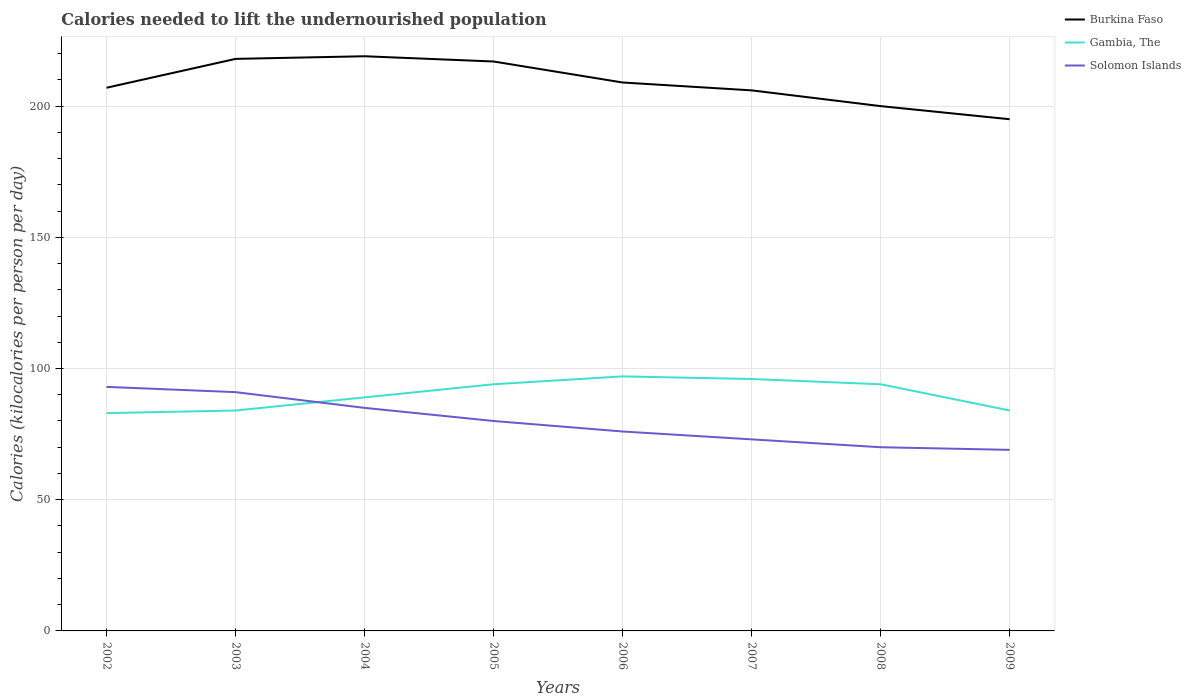Does the line corresponding to Solomon Islands intersect with the line corresponding to Burkina Faso?
Provide a short and direct response. No. Is the number of lines equal to the number of legend labels?
Your answer should be very brief. Yes. Across all years, what is the maximum total calories needed to lift the undernourished population in Gambia, The?
Keep it short and to the point. 83. What is the total total calories needed to lift the undernourished population in Solomon Islands in the graph?
Ensure brevity in your answer.  12. What is the difference between the highest and the second highest total calories needed to lift the undernourished population in Burkina Faso?
Provide a short and direct response. 24. What is the difference between the highest and the lowest total calories needed to lift the undernourished population in Burkina Faso?
Give a very brief answer. 4. What is the difference between two consecutive major ticks on the Y-axis?
Offer a terse response. 50. Does the graph contain grids?
Ensure brevity in your answer.  Yes. Where does the legend appear in the graph?
Ensure brevity in your answer.  Top right. How many legend labels are there?
Make the answer very short. 3. How are the legend labels stacked?
Offer a very short reply. Vertical. What is the title of the graph?
Your response must be concise. Calories needed to lift the undernourished population. What is the label or title of the X-axis?
Provide a short and direct response. Years. What is the label or title of the Y-axis?
Provide a short and direct response. Calories (kilocalories per person per day). What is the Calories (kilocalories per person per day) in Burkina Faso in 2002?
Provide a succinct answer. 207. What is the Calories (kilocalories per person per day) in Gambia, The in 2002?
Make the answer very short. 83. What is the Calories (kilocalories per person per day) in Solomon Islands in 2002?
Your answer should be very brief. 93. What is the Calories (kilocalories per person per day) in Burkina Faso in 2003?
Your answer should be very brief. 218. What is the Calories (kilocalories per person per day) in Gambia, The in 2003?
Ensure brevity in your answer.  84. What is the Calories (kilocalories per person per day) of Solomon Islands in 2003?
Make the answer very short. 91. What is the Calories (kilocalories per person per day) of Burkina Faso in 2004?
Keep it short and to the point. 219. What is the Calories (kilocalories per person per day) in Gambia, The in 2004?
Your response must be concise. 89. What is the Calories (kilocalories per person per day) in Burkina Faso in 2005?
Give a very brief answer. 217. What is the Calories (kilocalories per person per day) of Gambia, The in 2005?
Ensure brevity in your answer.  94. What is the Calories (kilocalories per person per day) of Solomon Islands in 2005?
Give a very brief answer. 80. What is the Calories (kilocalories per person per day) in Burkina Faso in 2006?
Your answer should be compact. 209. What is the Calories (kilocalories per person per day) of Gambia, The in 2006?
Make the answer very short. 97. What is the Calories (kilocalories per person per day) of Burkina Faso in 2007?
Keep it short and to the point. 206. What is the Calories (kilocalories per person per day) of Gambia, The in 2007?
Give a very brief answer. 96. What is the Calories (kilocalories per person per day) of Burkina Faso in 2008?
Provide a succinct answer. 200. What is the Calories (kilocalories per person per day) in Gambia, The in 2008?
Your answer should be very brief. 94. What is the Calories (kilocalories per person per day) in Solomon Islands in 2008?
Your response must be concise. 70. What is the Calories (kilocalories per person per day) of Burkina Faso in 2009?
Your answer should be compact. 195. Across all years, what is the maximum Calories (kilocalories per person per day) in Burkina Faso?
Give a very brief answer. 219. Across all years, what is the maximum Calories (kilocalories per person per day) of Gambia, The?
Provide a short and direct response. 97. Across all years, what is the maximum Calories (kilocalories per person per day) of Solomon Islands?
Your answer should be compact. 93. Across all years, what is the minimum Calories (kilocalories per person per day) of Burkina Faso?
Your response must be concise. 195. Across all years, what is the minimum Calories (kilocalories per person per day) of Solomon Islands?
Ensure brevity in your answer.  69. What is the total Calories (kilocalories per person per day) of Burkina Faso in the graph?
Your answer should be very brief. 1671. What is the total Calories (kilocalories per person per day) of Gambia, The in the graph?
Your answer should be very brief. 721. What is the total Calories (kilocalories per person per day) of Solomon Islands in the graph?
Your response must be concise. 637. What is the difference between the Calories (kilocalories per person per day) in Gambia, The in 2002 and that in 2003?
Your answer should be compact. -1. What is the difference between the Calories (kilocalories per person per day) of Gambia, The in 2002 and that in 2004?
Give a very brief answer. -6. What is the difference between the Calories (kilocalories per person per day) of Solomon Islands in 2002 and that in 2004?
Provide a short and direct response. 8. What is the difference between the Calories (kilocalories per person per day) of Solomon Islands in 2002 and that in 2005?
Make the answer very short. 13. What is the difference between the Calories (kilocalories per person per day) in Burkina Faso in 2002 and that in 2006?
Offer a very short reply. -2. What is the difference between the Calories (kilocalories per person per day) in Gambia, The in 2002 and that in 2007?
Give a very brief answer. -13. What is the difference between the Calories (kilocalories per person per day) in Solomon Islands in 2002 and that in 2007?
Give a very brief answer. 20. What is the difference between the Calories (kilocalories per person per day) of Burkina Faso in 2002 and that in 2009?
Keep it short and to the point. 12. What is the difference between the Calories (kilocalories per person per day) in Gambia, The in 2002 and that in 2009?
Keep it short and to the point. -1. What is the difference between the Calories (kilocalories per person per day) of Gambia, The in 2003 and that in 2004?
Your response must be concise. -5. What is the difference between the Calories (kilocalories per person per day) in Solomon Islands in 2003 and that in 2005?
Ensure brevity in your answer.  11. What is the difference between the Calories (kilocalories per person per day) in Burkina Faso in 2003 and that in 2006?
Ensure brevity in your answer.  9. What is the difference between the Calories (kilocalories per person per day) of Gambia, The in 2003 and that in 2006?
Provide a short and direct response. -13. What is the difference between the Calories (kilocalories per person per day) in Solomon Islands in 2003 and that in 2006?
Offer a very short reply. 15. What is the difference between the Calories (kilocalories per person per day) of Gambia, The in 2003 and that in 2007?
Your response must be concise. -12. What is the difference between the Calories (kilocalories per person per day) in Solomon Islands in 2003 and that in 2007?
Provide a short and direct response. 18. What is the difference between the Calories (kilocalories per person per day) in Burkina Faso in 2003 and that in 2008?
Provide a short and direct response. 18. What is the difference between the Calories (kilocalories per person per day) of Gambia, The in 2003 and that in 2008?
Offer a terse response. -10. What is the difference between the Calories (kilocalories per person per day) in Burkina Faso in 2003 and that in 2009?
Your answer should be compact. 23. What is the difference between the Calories (kilocalories per person per day) in Gambia, The in 2003 and that in 2009?
Ensure brevity in your answer.  0. What is the difference between the Calories (kilocalories per person per day) of Solomon Islands in 2003 and that in 2009?
Provide a short and direct response. 22. What is the difference between the Calories (kilocalories per person per day) in Burkina Faso in 2004 and that in 2005?
Offer a terse response. 2. What is the difference between the Calories (kilocalories per person per day) in Gambia, The in 2004 and that in 2005?
Your answer should be very brief. -5. What is the difference between the Calories (kilocalories per person per day) in Solomon Islands in 2004 and that in 2005?
Ensure brevity in your answer.  5. What is the difference between the Calories (kilocalories per person per day) in Gambia, The in 2004 and that in 2006?
Your answer should be very brief. -8. What is the difference between the Calories (kilocalories per person per day) in Burkina Faso in 2004 and that in 2007?
Ensure brevity in your answer.  13. What is the difference between the Calories (kilocalories per person per day) of Solomon Islands in 2004 and that in 2007?
Give a very brief answer. 12. What is the difference between the Calories (kilocalories per person per day) in Gambia, The in 2004 and that in 2008?
Provide a short and direct response. -5. What is the difference between the Calories (kilocalories per person per day) of Solomon Islands in 2004 and that in 2008?
Provide a succinct answer. 15. What is the difference between the Calories (kilocalories per person per day) of Solomon Islands in 2004 and that in 2009?
Your answer should be compact. 16. What is the difference between the Calories (kilocalories per person per day) of Burkina Faso in 2005 and that in 2006?
Your answer should be compact. 8. What is the difference between the Calories (kilocalories per person per day) of Gambia, The in 2005 and that in 2006?
Make the answer very short. -3. What is the difference between the Calories (kilocalories per person per day) of Solomon Islands in 2005 and that in 2006?
Give a very brief answer. 4. What is the difference between the Calories (kilocalories per person per day) in Solomon Islands in 2005 and that in 2007?
Give a very brief answer. 7. What is the difference between the Calories (kilocalories per person per day) of Burkina Faso in 2005 and that in 2008?
Your answer should be compact. 17. What is the difference between the Calories (kilocalories per person per day) in Solomon Islands in 2005 and that in 2008?
Offer a very short reply. 10. What is the difference between the Calories (kilocalories per person per day) in Burkina Faso in 2005 and that in 2009?
Provide a short and direct response. 22. What is the difference between the Calories (kilocalories per person per day) of Gambia, The in 2005 and that in 2009?
Ensure brevity in your answer.  10. What is the difference between the Calories (kilocalories per person per day) in Solomon Islands in 2005 and that in 2009?
Your response must be concise. 11. What is the difference between the Calories (kilocalories per person per day) of Gambia, The in 2006 and that in 2007?
Your answer should be very brief. 1. What is the difference between the Calories (kilocalories per person per day) of Gambia, The in 2007 and that in 2009?
Ensure brevity in your answer.  12. What is the difference between the Calories (kilocalories per person per day) in Solomon Islands in 2007 and that in 2009?
Your answer should be compact. 4. What is the difference between the Calories (kilocalories per person per day) in Burkina Faso in 2008 and that in 2009?
Offer a very short reply. 5. What is the difference between the Calories (kilocalories per person per day) of Solomon Islands in 2008 and that in 2009?
Your answer should be very brief. 1. What is the difference between the Calories (kilocalories per person per day) of Burkina Faso in 2002 and the Calories (kilocalories per person per day) of Gambia, The in 2003?
Provide a succinct answer. 123. What is the difference between the Calories (kilocalories per person per day) in Burkina Faso in 2002 and the Calories (kilocalories per person per day) in Solomon Islands in 2003?
Your answer should be very brief. 116. What is the difference between the Calories (kilocalories per person per day) in Burkina Faso in 2002 and the Calories (kilocalories per person per day) in Gambia, The in 2004?
Offer a terse response. 118. What is the difference between the Calories (kilocalories per person per day) of Burkina Faso in 2002 and the Calories (kilocalories per person per day) of Solomon Islands in 2004?
Your response must be concise. 122. What is the difference between the Calories (kilocalories per person per day) of Gambia, The in 2002 and the Calories (kilocalories per person per day) of Solomon Islands in 2004?
Offer a terse response. -2. What is the difference between the Calories (kilocalories per person per day) of Burkina Faso in 2002 and the Calories (kilocalories per person per day) of Gambia, The in 2005?
Keep it short and to the point. 113. What is the difference between the Calories (kilocalories per person per day) in Burkina Faso in 2002 and the Calories (kilocalories per person per day) in Solomon Islands in 2005?
Make the answer very short. 127. What is the difference between the Calories (kilocalories per person per day) in Gambia, The in 2002 and the Calories (kilocalories per person per day) in Solomon Islands in 2005?
Offer a terse response. 3. What is the difference between the Calories (kilocalories per person per day) of Burkina Faso in 2002 and the Calories (kilocalories per person per day) of Gambia, The in 2006?
Offer a terse response. 110. What is the difference between the Calories (kilocalories per person per day) in Burkina Faso in 2002 and the Calories (kilocalories per person per day) in Solomon Islands in 2006?
Offer a terse response. 131. What is the difference between the Calories (kilocalories per person per day) of Gambia, The in 2002 and the Calories (kilocalories per person per day) of Solomon Islands in 2006?
Provide a short and direct response. 7. What is the difference between the Calories (kilocalories per person per day) of Burkina Faso in 2002 and the Calories (kilocalories per person per day) of Gambia, The in 2007?
Keep it short and to the point. 111. What is the difference between the Calories (kilocalories per person per day) in Burkina Faso in 2002 and the Calories (kilocalories per person per day) in Solomon Islands in 2007?
Offer a terse response. 134. What is the difference between the Calories (kilocalories per person per day) of Burkina Faso in 2002 and the Calories (kilocalories per person per day) of Gambia, The in 2008?
Your answer should be very brief. 113. What is the difference between the Calories (kilocalories per person per day) of Burkina Faso in 2002 and the Calories (kilocalories per person per day) of Solomon Islands in 2008?
Keep it short and to the point. 137. What is the difference between the Calories (kilocalories per person per day) in Burkina Faso in 2002 and the Calories (kilocalories per person per day) in Gambia, The in 2009?
Give a very brief answer. 123. What is the difference between the Calories (kilocalories per person per day) in Burkina Faso in 2002 and the Calories (kilocalories per person per day) in Solomon Islands in 2009?
Offer a terse response. 138. What is the difference between the Calories (kilocalories per person per day) of Gambia, The in 2002 and the Calories (kilocalories per person per day) of Solomon Islands in 2009?
Make the answer very short. 14. What is the difference between the Calories (kilocalories per person per day) in Burkina Faso in 2003 and the Calories (kilocalories per person per day) in Gambia, The in 2004?
Offer a terse response. 129. What is the difference between the Calories (kilocalories per person per day) in Burkina Faso in 2003 and the Calories (kilocalories per person per day) in Solomon Islands in 2004?
Your answer should be compact. 133. What is the difference between the Calories (kilocalories per person per day) of Burkina Faso in 2003 and the Calories (kilocalories per person per day) of Gambia, The in 2005?
Provide a short and direct response. 124. What is the difference between the Calories (kilocalories per person per day) in Burkina Faso in 2003 and the Calories (kilocalories per person per day) in Solomon Islands in 2005?
Keep it short and to the point. 138. What is the difference between the Calories (kilocalories per person per day) of Gambia, The in 2003 and the Calories (kilocalories per person per day) of Solomon Islands in 2005?
Your answer should be compact. 4. What is the difference between the Calories (kilocalories per person per day) in Burkina Faso in 2003 and the Calories (kilocalories per person per day) in Gambia, The in 2006?
Your answer should be very brief. 121. What is the difference between the Calories (kilocalories per person per day) of Burkina Faso in 2003 and the Calories (kilocalories per person per day) of Solomon Islands in 2006?
Make the answer very short. 142. What is the difference between the Calories (kilocalories per person per day) in Gambia, The in 2003 and the Calories (kilocalories per person per day) in Solomon Islands in 2006?
Offer a very short reply. 8. What is the difference between the Calories (kilocalories per person per day) in Burkina Faso in 2003 and the Calories (kilocalories per person per day) in Gambia, The in 2007?
Make the answer very short. 122. What is the difference between the Calories (kilocalories per person per day) in Burkina Faso in 2003 and the Calories (kilocalories per person per day) in Solomon Islands in 2007?
Make the answer very short. 145. What is the difference between the Calories (kilocalories per person per day) in Burkina Faso in 2003 and the Calories (kilocalories per person per day) in Gambia, The in 2008?
Your answer should be very brief. 124. What is the difference between the Calories (kilocalories per person per day) of Burkina Faso in 2003 and the Calories (kilocalories per person per day) of Solomon Islands in 2008?
Provide a succinct answer. 148. What is the difference between the Calories (kilocalories per person per day) of Burkina Faso in 2003 and the Calories (kilocalories per person per day) of Gambia, The in 2009?
Make the answer very short. 134. What is the difference between the Calories (kilocalories per person per day) in Burkina Faso in 2003 and the Calories (kilocalories per person per day) in Solomon Islands in 2009?
Provide a succinct answer. 149. What is the difference between the Calories (kilocalories per person per day) in Gambia, The in 2003 and the Calories (kilocalories per person per day) in Solomon Islands in 2009?
Keep it short and to the point. 15. What is the difference between the Calories (kilocalories per person per day) of Burkina Faso in 2004 and the Calories (kilocalories per person per day) of Gambia, The in 2005?
Ensure brevity in your answer.  125. What is the difference between the Calories (kilocalories per person per day) of Burkina Faso in 2004 and the Calories (kilocalories per person per day) of Solomon Islands in 2005?
Your answer should be compact. 139. What is the difference between the Calories (kilocalories per person per day) in Burkina Faso in 2004 and the Calories (kilocalories per person per day) in Gambia, The in 2006?
Give a very brief answer. 122. What is the difference between the Calories (kilocalories per person per day) of Burkina Faso in 2004 and the Calories (kilocalories per person per day) of Solomon Islands in 2006?
Provide a short and direct response. 143. What is the difference between the Calories (kilocalories per person per day) of Burkina Faso in 2004 and the Calories (kilocalories per person per day) of Gambia, The in 2007?
Your response must be concise. 123. What is the difference between the Calories (kilocalories per person per day) in Burkina Faso in 2004 and the Calories (kilocalories per person per day) in Solomon Islands in 2007?
Your answer should be very brief. 146. What is the difference between the Calories (kilocalories per person per day) in Burkina Faso in 2004 and the Calories (kilocalories per person per day) in Gambia, The in 2008?
Your response must be concise. 125. What is the difference between the Calories (kilocalories per person per day) in Burkina Faso in 2004 and the Calories (kilocalories per person per day) in Solomon Islands in 2008?
Provide a short and direct response. 149. What is the difference between the Calories (kilocalories per person per day) of Burkina Faso in 2004 and the Calories (kilocalories per person per day) of Gambia, The in 2009?
Offer a terse response. 135. What is the difference between the Calories (kilocalories per person per day) of Burkina Faso in 2004 and the Calories (kilocalories per person per day) of Solomon Islands in 2009?
Offer a terse response. 150. What is the difference between the Calories (kilocalories per person per day) in Gambia, The in 2004 and the Calories (kilocalories per person per day) in Solomon Islands in 2009?
Offer a very short reply. 20. What is the difference between the Calories (kilocalories per person per day) of Burkina Faso in 2005 and the Calories (kilocalories per person per day) of Gambia, The in 2006?
Give a very brief answer. 120. What is the difference between the Calories (kilocalories per person per day) of Burkina Faso in 2005 and the Calories (kilocalories per person per day) of Solomon Islands in 2006?
Your answer should be compact. 141. What is the difference between the Calories (kilocalories per person per day) in Gambia, The in 2005 and the Calories (kilocalories per person per day) in Solomon Islands in 2006?
Make the answer very short. 18. What is the difference between the Calories (kilocalories per person per day) of Burkina Faso in 2005 and the Calories (kilocalories per person per day) of Gambia, The in 2007?
Make the answer very short. 121. What is the difference between the Calories (kilocalories per person per day) of Burkina Faso in 2005 and the Calories (kilocalories per person per day) of Solomon Islands in 2007?
Ensure brevity in your answer.  144. What is the difference between the Calories (kilocalories per person per day) of Gambia, The in 2005 and the Calories (kilocalories per person per day) of Solomon Islands in 2007?
Provide a succinct answer. 21. What is the difference between the Calories (kilocalories per person per day) of Burkina Faso in 2005 and the Calories (kilocalories per person per day) of Gambia, The in 2008?
Provide a short and direct response. 123. What is the difference between the Calories (kilocalories per person per day) of Burkina Faso in 2005 and the Calories (kilocalories per person per day) of Solomon Islands in 2008?
Offer a very short reply. 147. What is the difference between the Calories (kilocalories per person per day) of Gambia, The in 2005 and the Calories (kilocalories per person per day) of Solomon Islands in 2008?
Your response must be concise. 24. What is the difference between the Calories (kilocalories per person per day) in Burkina Faso in 2005 and the Calories (kilocalories per person per day) in Gambia, The in 2009?
Your answer should be very brief. 133. What is the difference between the Calories (kilocalories per person per day) of Burkina Faso in 2005 and the Calories (kilocalories per person per day) of Solomon Islands in 2009?
Offer a terse response. 148. What is the difference between the Calories (kilocalories per person per day) of Gambia, The in 2005 and the Calories (kilocalories per person per day) of Solomon Islands in 2009?
Give a very brief answer. 25. What is the difference between the Calories (kilocalories per person per day) of Burkina Faso in 2006 and the Calories (kilocalories per person per day) of Gambia, The in 2007?
Provide a succinct answer. 113. What is the difference between the Calories (kilocalories per person per day) in Burkina Faso in 2006 and the Calories (kilocalories per person per day) in Solomon Islands in 2007?
Provide a short and direct response. 136. What is the difference between the Calories (kilocalories per person per day) of Burkina Faso in 2006 and the Calories (kilocalories per person per day) of Gambia, The in 2008?
Ensure brevity in your answer.  115. What is the difference between the Calories (kilocalories per person per day) in Burkina Faso in 2006 and the Calories (kilocalories per person per day) in Solomon Islands in 2008?
Your answer should be compact. 139. What is the difference between the Calories (kilocalories per person per day) in Burkina Faso in 2006 and the Calories (kilocalories per person per day) in Gambia, The in 2009?
Offer a very short reply. 125. What is the difference between the Calories (kilocalories per person per day) in Burkina Faso in 2006 and the Calories (kilocalories per person per day) in Solomon Islands in 2009?
Provide a short and direct response. 140. What is the difference between the Calories (kilocalories per person per day) in Gambia, The in 2006 and the Calories (kilocalories per person per day) in Solomon Islands in 2009?
Provide a succinct answer. 28. What is the difference between the Calories (kilocalories per person per day) in Burkina Faso in 2007 and the Calories (kilocalories per person per day) in Gambia, The in 2008?
Offer a very short reply. 112. What is the difference between the Calories (kilocalories per person per day) in Burkina Faso in 2007 and the Calories (kilocalories per person per day) in Solomon Islands in 2008?
Ensure brevity in your answer.  136. What is the difference between the Calories (kilocalories per person per day) of Burkina Faso in 2007 and the Calories (kilocalories per person per day) of Gambia, The in 2009?
Offer a very short reply. 122. What is the difference between the Calories (kilocalories per person per day) in Burkina Faso in 2007 and the Calories (kilocalories per person per day) in Solomon Islands in 2009?
Provide a succinct answer. 137. What is the difference between the Calories (kilocalories per person per day) of Gambia, The in 2007 and the Calories (kilocalories per person per day) of Solomon Islands in 2009?
Your response must be concise. 27. What is the difference between the Calories (kilocalories per person per day) in Burkina Faso in 2008 and the Calories (kilocalories per person per day) in Gambia, The in 2009?
Provide a succinct answer. 116. What is the difference between the Calories (kilocalories per person per day) in Burkina Faso in 2008 and the Calories (kilocalories per person per day) in Solomon Islands in 2009?
Keep it short and to the point. 131. What is the difference between the Calories (kilocalories per person per day) in Gambia, The in 2008 and the Calories (kilocalories per person per day) in Solomon Islands in 2009?
Give a very brief answer. 25. What is the average Calories (kilocalories per person per day) of Burkina Faso per year?
Your answer should be very brief. 208.88. What is the average Calories (kilocalories per person per day) in Gambia, The per year?
Your answer should be compact. 90.12. What is the average Calories (kilocalories per person per day) in Solomon Islands per year?
Offer a very short reply. 79.62. In the year 2002, what is the difference between the Calories (kilocalories per person per day) in Burkina Faso and Calories (kilocalories per person per day) in Gambia, The?
Provide a succinct answer. 124. In the year 2002, what is the difference between the Calories (kilocalories per person per day) of Burkina Faso and Calories (kilocalories per person per day) of Solomon Islands?
Provide a short and direct response. 114. In the year 2003, what is the difference between the Calories (kilocalories per person per day) in Burkina Faso and Calories (kilocalories per person per day) in Gambia, The?
Provide a succinct answer. 134. In the year 2003, what is the difference between the Calories (kilocalories per person per day) of Burkina Faso and Calories (kilocalories per person per day) of Solomon Islands?
Ensure brevity in your answer.  127. In the year 2003, what is the difference between the Calories (kilocalories per person per day) in Gambia, The and Calories (kilocalories per person per day) in Solomon Islands?
Your answer should be compact. -7. In the year 2004, what is the difference between the Calories (kilocalories per person per day) in Burkina Faso and Calories (kilocalories per person per day) in Gambia, The?
Provide a succinct answer. 130. In the year 2004, what is the difference between the Calories (kilocalories per person per day) in Burkina Faso and Calories (kilocalories per person per day) in Solomon Islands?
Make the answer very short. 134. In the year 2004, what is the difference between the Calories (kilocalories per person per day) of Gambia, The and Calories (kilocalories per person per day) of Solomon Islands?
Your response must be concise. 4. In the year 2005, what is the difference between the Calories (kilocalories per person per day) of Burkina Faso and Calories (kilocalories per person per day) of Gambia, The?
Provide a succinct answer. 123. In the year 2005, what is the difference between the Calories (kilocalories per person per day) in Burkina Faso and Calories (kilocalories per person per day) in Solomon Islands?
Your answer should be compact. 137. In the year 2005, what is the difference between the Calories (kilocalories per person per day) in Gambia, The and Calories (kilocalories per person per day) in Solomon Islands?
Make the answer very short. 14. In the year 2006, what is the difference between the Calories (kilocalories per person per day) in Burkina Faso and Calories (kilocalories per person per day) in Gambia, The?
Keep it short and to the point. 112. In the year 2006, what is the difference between the Calories (kilocalories per person per day) in Burkina Faso and Calories (kilocalories per person per day) in Solomon Islands?
Keep it short and to the point. 133. In the year 2007, what is the difference between the Calories (kilocalories per person per day) in Burkina Faso and Calories (kilocalories per person per day) in Gambia, The?
Ensure brevity in your answer.  110. In the year 2007, what is the difference between the Calories (kilocalories per person per day) in Burkina Faso and Calories (kilocalories per person per day) in Solomon Islands?
Your answer should be compact. 133. In the year 2008, what is the difference between the Calories (kilocalories per person per day) of Burkina Faso and Calories (kilocalories per person per day) of Gambia, The?
Make the answer very short. 106. In the year 2008, what is the difference between the Calories (kilocalories per person per day) of Burkina Faso and Calories (kilocalories per person per day) of Solomon Islands?
Your response must be concise. 130. In the year 2009, what is the difference between the Calories (kilocalories per person per day) in Burkina Faso and Calories (kilocalories per person per day) in Gambia, The?
Your answer should be compact. 111. In the year 2009, what is the difference between the Calories (kilocalories per person per day) of Burkina Faso and Calories (kilocalories per person per day) of Solomon Islands?
Your answer should be very brief. 126. In the year 2009, what is the difference between the Calories (kilocalories per person per day) of Gambia, The and Calories (kilocalories per person per day) of Solomon Islands?
Keep it short and to the point. 15. What is the ratio of the Calories (kilocalories per person per day) in Burkina Faso in 2002 to that in 2003?
Provide a succinct answer. 0.95. What is the ratio of the Calories (kilocalories per person per day) in Burkina Faso in 2002 to that in 2004?
Provide a short and direct response. 0.95. What is the ratio of the Calories (kilocalories per person per day) of Gambia, The in 2002 to that in 2004?
Your response must be concise. 0.93. What is the ratio of the Calories (kilocalories per person per day) of Solomon Islands in 2002 to that in 2004?
Provide a short and direct response. 1.09. What is the ratio of the Calories (kilocalories per person per day) of Burkina Faso in 2002 to that in 2005?
Your response must be concise. 0.95. What is the ratio of the Calories (kilocalories per person per day) in Gambia, The in 2002 to that in 2005?
Your answer should be compact. 0.88. What is the ratio of the Calories (kilocalories per person per day) of Solomon Islands in 2002 to that in 2005?
Give a very brief answer. 1.16. What is the ratio of the Calories (kilocalories per person per day) in Burkina Faso in 2002 to that in 2006?
Provide a succinct answer. 0.99. What is the ratio of the Calories (kilocalories per person per day) of Gambia, The in 2002 to that in 2006?
Provide a short and direct response. 0.86. What is the ratio of the Calories (kilocalories per person per day) of Solomon Islands in 2002 to that in 2006?
Your answer should be very brief. 1.22. What is the ratio of the Calories (kilocalories per person per day) in Burkina Faso in 2002 to that in 2007?
Your response must be concise. 1. What is the ratio of the Calories (kilocalories per person per day) in Gambia, The in 2002 to that in 2007?
Your answer should be very brief. 0.86. What is the ratio of the Calories (kilocalories per person per day) in Solomon Islands in 2002 to that in 2007?
Your answer should be very brief. 1.27. What is the ratio of the Calories (kilocalories per person per day) of Burkina Faso in 2002 to that in 2008?
Give a very brief answer. 1.03. What is the ratio of the Calories (kilocalories per person per day) in Gambia, The in 2002 to that in 2008?
Provide a short and direct response. 0.88. What is the ratio of the Calories (kilocalories per person per day) of Solomon Islands in 2002 to that in 2008?
Your response must be concise. 1.33. What is the ratio of the Calories (kilocalories per person per day) of Burkina Faso in 2002 to that in 2009?
Offer a very short reply. 1.06. What is the ratio of the Calories (kilocalories per person per day) of Gambia, The in 2002 to that in 2009?
Offer a terse response. 0.99. What is the ratio of the Calories (kilocalories per person per day) of Solomon Islands in 2002 to that in 2009?
Make the answer very short. 1.35. What is the ratio of the Calories (kilocalories per person per day) of Burkina Faso in 2003 to that in 2004?
Provide a short and direct response. 1. What is the ratio of the Calories (kilocalories per person per day) in Gambia, The in 2003 to that in 2004?
Your answer should be very brief. 0.94. What is the ratio of the Calories (kilocalories per person per day) of Solomon Islands in 2003 to that in 2004?
Keep it short and to the point. 1.07. What is the ratio of the Calories (kilocalories per person per day) of Gambia, The in 2003 to that in 2005?
Give a very brief answer. 0.89. What is the ratio of the Calories (kilocalories per person per day) in Solomon Islands in 2003 to that in 2005?
Make the answer very short. 1.14. What is the ratio of the Calories (kilocalories per person per day) of Burkina Faso in 2003 to that in 2006?
Make the answer very short. 1.04. What is the ratio of the Calories (kilocalories per person per day) in Gambia, The in 2003 to that in 2006?
Provide a short and direct response. 0.87. What is the ratio of the Calories (kilocalories per person per day) of Solomon Islands in 2003 to that in 2006?
Ensure brevity in your answer.  1.2. What is the ratio of the Calories (kilocalories per person per day) of Burkina Faso in 2003 to that in 2007?
Make the answer very short. 1.06. What is the ratio of the Calories (kilocalories per person per day) in Solomon Islands in 2003 to that in 2007?
Provide a short and direct response. 1.25. What is the ratio of the Calories (kilocalories per person per day) in Burkina Faso in 2003 to that in 2008?
Ensure brevity in your answer.  1.09. What is the ratio of the Calories (kilocalories per person per day) of Gambia, The in 2003 to that in 2008?
Provide a succinct answer. 0.89. What is the ratio of the Calories (kilocalories per person per day) in Solomon Islands in 2003 to that in 2008?
Your answer should be compact. 1.3. What is the ratio of the Calories (kilocalories per person per day) of Burkina Faso in 2003 to that in 2009?
Your answer should be very brief. 1.12. What is the ratio of the Calories (kilocalories per person per day) in Gambia, The in 2003 to that in 2009?
Give a very brief answer. 1. What is the ratio of the Calories (kilocalories per person per day) in Solomon Islands in 2003 to that in 2009?
Keep it short and to the point. 1.32. What is the ratio of the Calories (kilocalories per person per day) of Burkina Faso in 2004 to that in 2005?
Your response must be concise. 1.01. What is the ratio of the Calories (kilocalories per person per day) in Gambia, The in 2004 to that in 2005?
Your answer should be compact. 0.95. What is the ratio of the Calories (kilocalories per person per day) of Burkina Faso in 2004 to that in 2006?
Your answer should be compact. 1.05. What is the ratio of the Calories (kilocalories per person per day) in Gambia, The in 2004 to that in 2006?
Give a very brief answer. 0.92. What is the ratio of the Calories (kilocalories per person per day) of Solomon Islands in 2004 to that in 2006?
Provide a succinct answer. 1.12. What is the ratio of the Calories (kilocalories per person per day) in Burkina Faso in 2004 to that in 2007?
Give a very brief answer. 1.06. What is the ratio of the Calories (kilocalories per person per day) of Gambia, The in 2004 to that in 2007?
Provide a succinct answer. 0.93. What is the ratio of the Calories (kilocalories per person per day) in Solomon Islands in 2004 to that in 2007?
Give a very brief answer. 1.16. What is the ratio of the Calories (kilocalories per person per day) in Burkina Faso in 2004 to that in 2008?
Keep it short and to the point. 1.09. What is the ratio of the Calories (kilocalories per person per day) in Gambia, The in 2004 to that in 2008?
Offer a very short reply. 0.95. What is the ratio of the Calories (kilocalories per person per day) in Solomon Islands in 2004 to that in 2008?
Give a very brief answer. 1.21. What is the ratio of the Calories (kilocalories per person per day) of Burkina Faso in 2004 to that in 2009?
Your answer should be very brief. 1.12. What is the ratio of the Calories (kilocalories per person per day) in Gambia, The in 2004 to that in 2009?
Ensure brevity in your answer.  1.06. What is the ratio of the Calories (kilocalories per person per day) of Solomon Islands in 2004 to that in 2009?
Your answer should be very brief. 1.23. What is the ratio of the Calories (kilocalories per person per day) in Burkina Faso in 2005 to that in 2006?
Offer a very short reply. 1.04. What is the ratio of the Calories (kilocalories per person per day) in Gambia, The in 2005 to that in 2006?
Keep it short and to the point. 0.97. What is the ratio of the Calories (kilocalories per person per day) in Solomon Islands in 2005 to that in 2006?
Keep it short and to the point. 1.05. What is the ratio of the Calories (kilocalories per person per day) in Burkina Faso in 2005 to that in 2007?
Your response must be concise. 1.05. What is the ratio of the Calories (kilocalories per person per day) of Gambia, The in 2005 to that in 2007?
Provide a short and direct response. 0.98. What is the ratio of the Calories (kilocalories per person per day) in Solomon Islands in 2005 to that in 2007?
Make the answer very short. 1.1. What is the ratio of the Calories (kilocalories per person per day) in Burkina Faso in 2005 to that in 2008?
Your answer should be compact. 1.08. What is the ratio of the Calories (kilocalories per person per day) in Gambia, The in 2005 to that in 2008?
Provide a short and direct response. 1. What is the ratio of the Calories (kilocalories per person per day) in Burkina Faso in 2005 to that in 2009?
Make the answer very short. 1.11. What is the ratio of the Calories (kilocalories per person per day) of Gambia, The in 2005 to that in 2009?
Your response must be concise. 1.12. What is the ratio of the Calories (kilocalories per person per day) in Solomon Islands in 2005 to that in 2009?
Your response must be concise. 1.16. What is the ratio of the Calories (kilocalories per person per day) of Burkina Faso in 2006 to that in 2007?
Ensure brevity in your answer.  1.01. What is the ratio of the Calories (kilocalories per person per day) in Gambia, The in 2006 to that in 2007?
Keep it short and to the point. 1.01. What is the ratio of the Calories (kilocalories per person per day) of Solomon Islands in 2006 to that in 2007?
Make the answer very short. 1.04. What is the ratio of the Calories (kilocalories per person per day) in Burkina Faso in 2006 to that in 2008?
Give a very brief answer. 1.04. What is the ratio of the Calories (kilocalories per person per day) of Gambia, The in 2006 to that in 2008?
Offer a very short reply. 1.03. What is the ratio of the Calories (kilocalories per person per day) in Solomon Islands in 2006 to that in 2008?
Keep it short and to the point. 1.09. What is the ratio of the Calories (kilocalories per person per day) of Burkina Faso in 2006 to that in 2009?
Make the answer very short. 1.07. What is the ratio of the Calories (kilocalories per person per day) in Gambia, The in 2006 to that in 2009?
Keep it short and to the point. 1.15. What is the ratio of the Calories (kilocalories per person per day) in Solomon Islands in 2006 to that in 2009?
Your answer should be very brief. 1.1. What is the ratio of the Calories (kilocalories per person per day) in Gambia, The in 2007 to that in 2008?
Your answer should be compact. 1.02. What is the ratio of the Calories (kilocalories per person per day) in Solomon Islands in 2007 to that in 2008?
Your answer should be compact. 1.04. What is the ratio of the Calories (kilocalories per person per day) of Burkina Faso in 2007 to that in 2009?
Offer a terse response. 1.06. What is the ratio of the Calories (kilocalories per person per day) of Solomon Islands in 2007 to that in 2009?
Give a very brief answer. 1.06. What is the ratio of the Calories (kilocalories per person per day) of Burkina Faso in 2008 to that in 2009?
Make the answer very short. 1.03. What is the ratio of the Calories (kilocalories per person per day) in Gambia, The in 2008 to that in 2009?
Keep it short and to the point. 1.12. What is the ratio of the Calories (kilocalories per person per day) in Solomon Islands in 2008 to that in 2009?
Keep it short and to the point. 1.01. What is the difference between the highest and the second highest Calories (kilocalories per person per day) of Solomon Islands?
Your answer should be very brief. 2. What is the difference between the highest and the lowest Calories (kilocalories per person per day) of Gambia, The?
Your answer should be very brief. 14. 